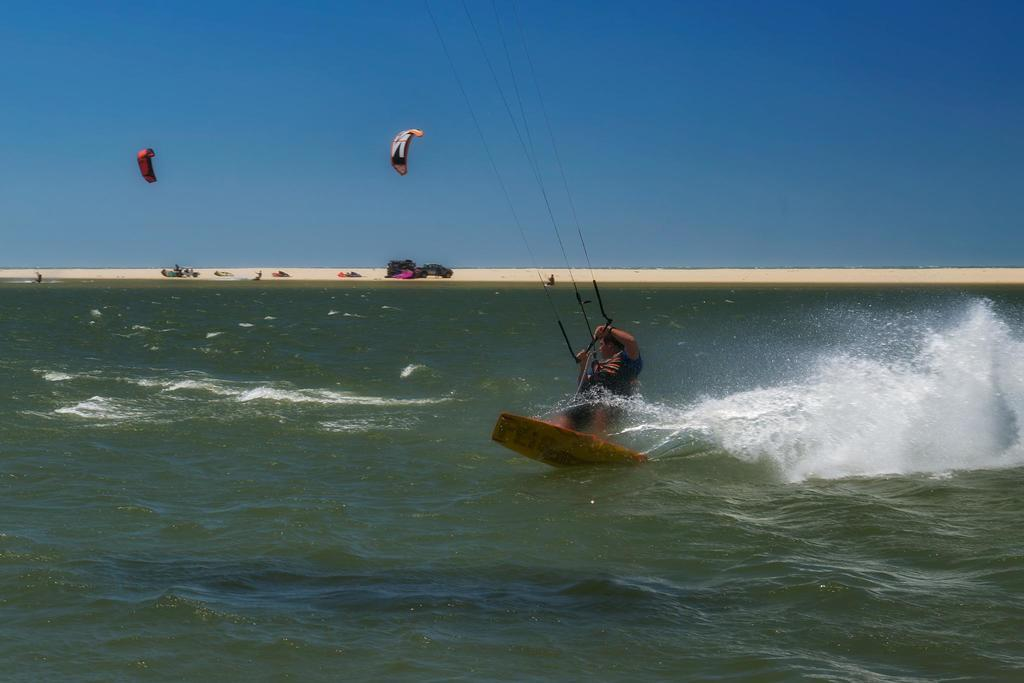What is the main feature of the landscape in the picture? There is an ocean in the picture. What is the man in the picture doing? The man is holding a rope in the picture. What type of terrain is visible in the backdrop of the picture? There is sand in the backdrop of the picture. What is the condition of the sky in the picture? The sky is clear in the picture. What type of knowledge can be gained from the star in the picture? There is no star present in the picture, so no knowledge can be gained from a star. How does the man in the picture perceive himself? The picture does not provide any information about the man's self-perception. 